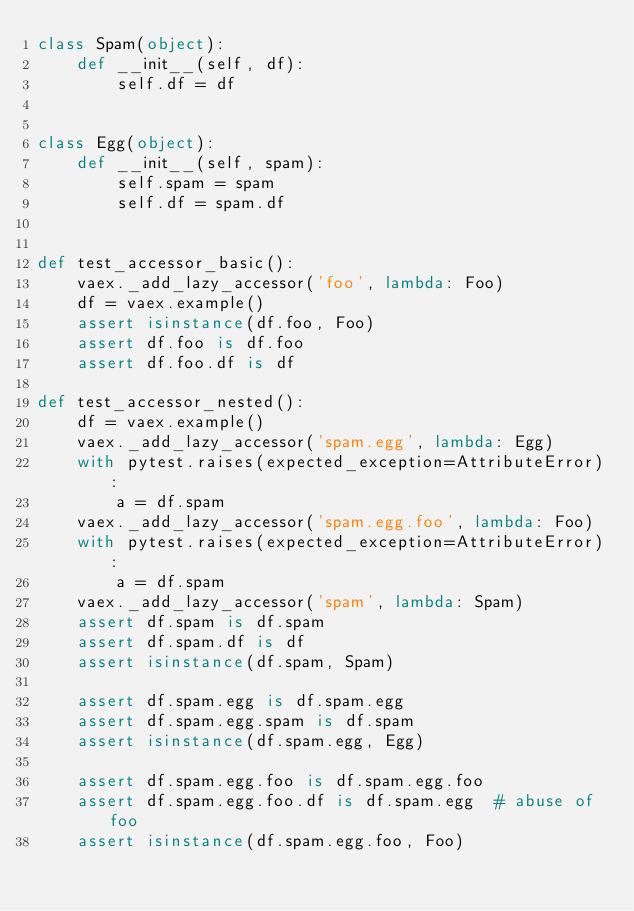<code> <loc_0><loc_0><loc_500><loc_500><_Python_>class Spam(object):
    def __init__(self, df):
        self.df = df


class Egg(object):
    def __init__(self, spam):
        self.spam = spam
        self.df = spam.df


def test_accessor_basic():
    vaex._add_lazy_accessor('foo', lambda: Foo)
    df = vaex.example()
    assert isinstance(df.foo, Foo)
    assert df.foo is df.foo
    assert df.foo.df is df

def test_accessor_nested():
    df = vaex.example()
    vaex._add_lazy_accessor('spam.egg', lambda: Egg)
    with pytest.raises(expected_exception=AttributeError):
        a = df.spam
    vaex._add_lazy_accessor('spam.egg.foo', lambda: Foo)
    with pytest.raises(expected_exception=AttributeError):
        a = df.spam
    vaex._add_lazy_accessor('spam', lambda: Spam)
    assert df.spam is df.spam
    assert df.spam.df is df
    assert isinstance(df.spam, Spam)

    assert df.spam.egg is df.spam.egg
    assert df.spam.egg.spam is df.spam
    assert isinstance(df.spam.egg, Egg)

    assert df.spam.egg.foo is df.spam.egg.foo
    assert df.spam.egg.foo.df is df.spam.egg  # abuse of foo
    assert isinstance(df.spam.egg.foo, Foo)
</code> 